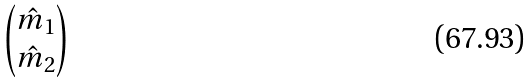Convert formula to latex. <formula><loc_0><loc_0><loc_500><loc_500>\begin{pmatrix} \hat { m } _ { 1 } \\ \hat { m } _ { 2 } \end{pmatrix}</formula> 